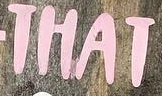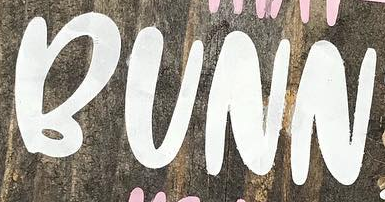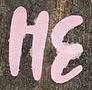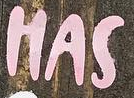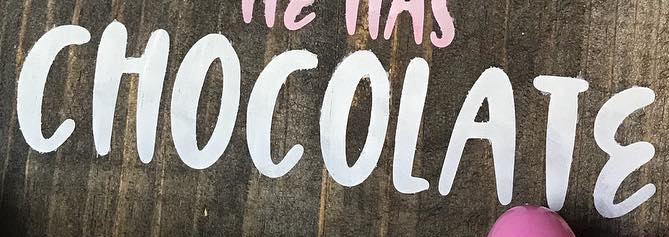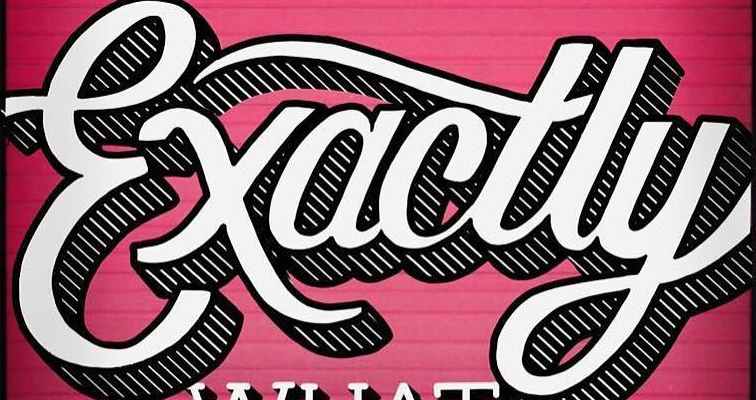What text appears in these images from left to right, separated by a semicolon? THAT; BUNN; HƐ; HAS; CHOCOLATƐ; Exactly 